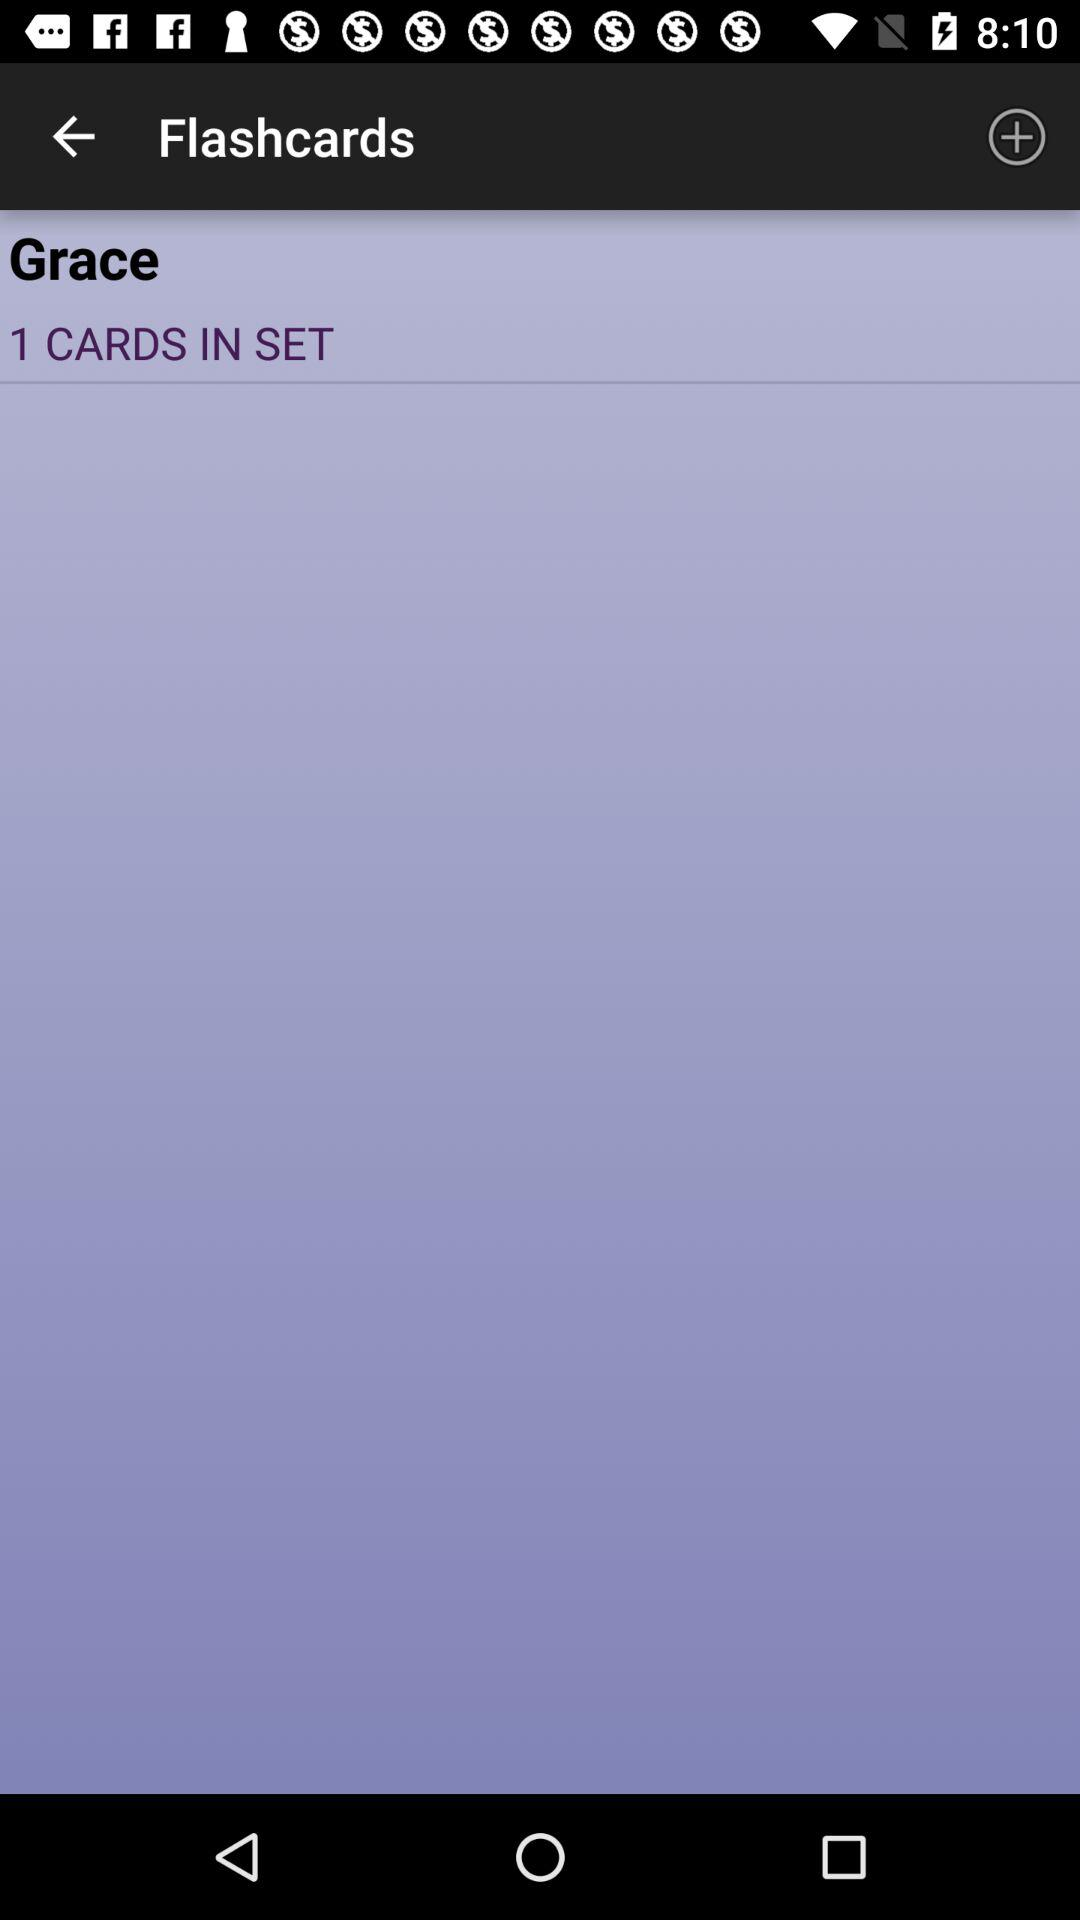How many cards are in the set?
Answer the question using a single word or phrase. 1 